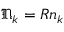Convert formula to latex. <formula><loc_0><loc_0><loc_500><loc_500>\mathfrak { N } _ { k } = R \mathfrak { n } _ { k }</formula> 